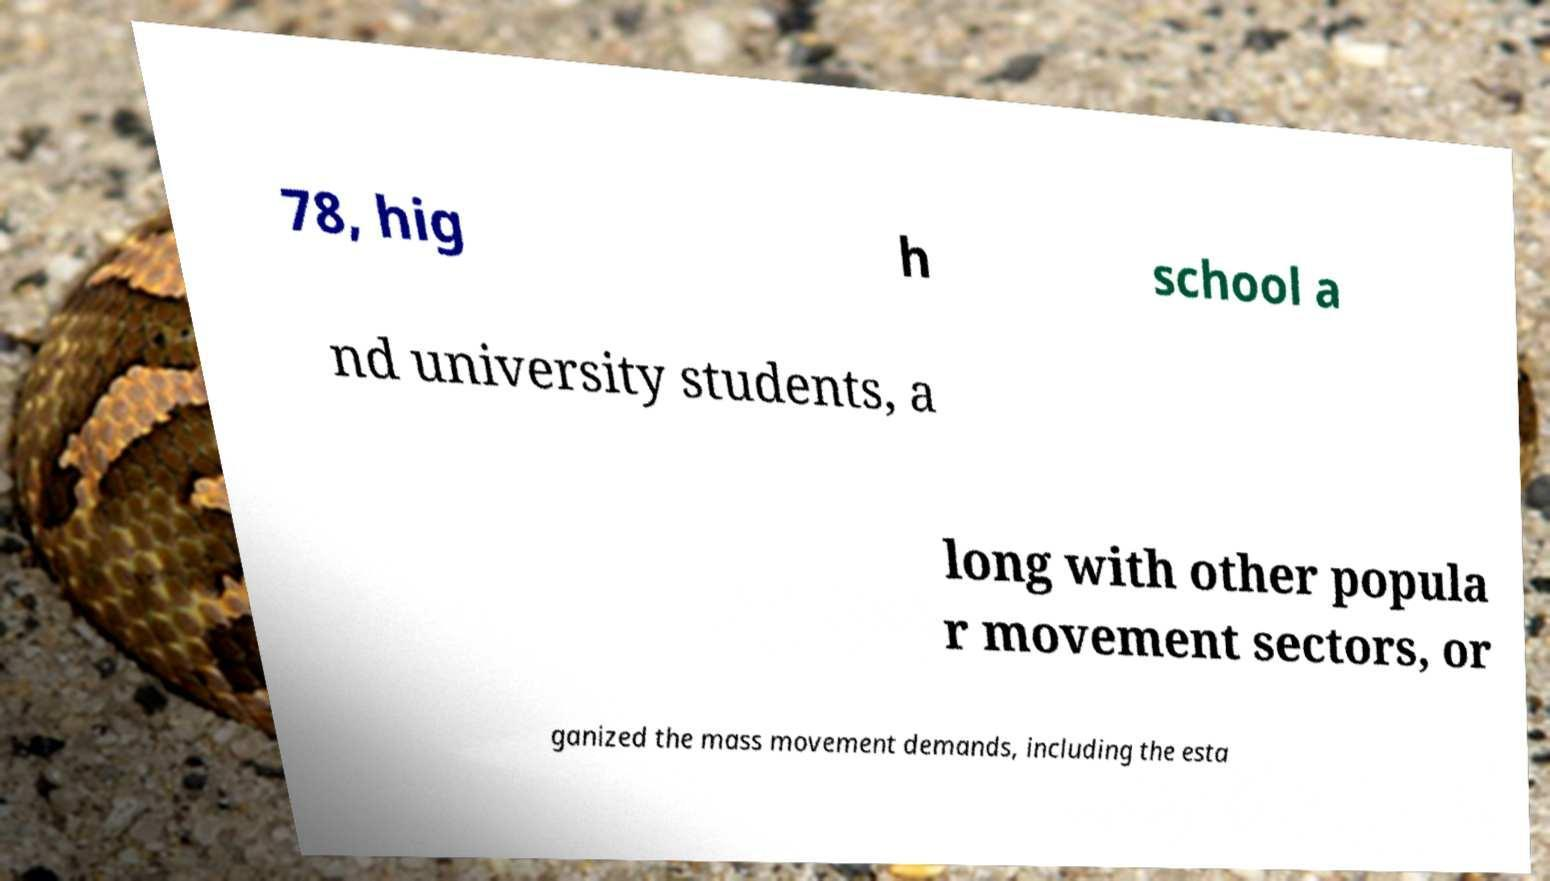Could you extract and type out the text from this image? 78, hig h school a nd university students, a long with other popula r movement sectors, or ganized the mass movement demands, including the esta 